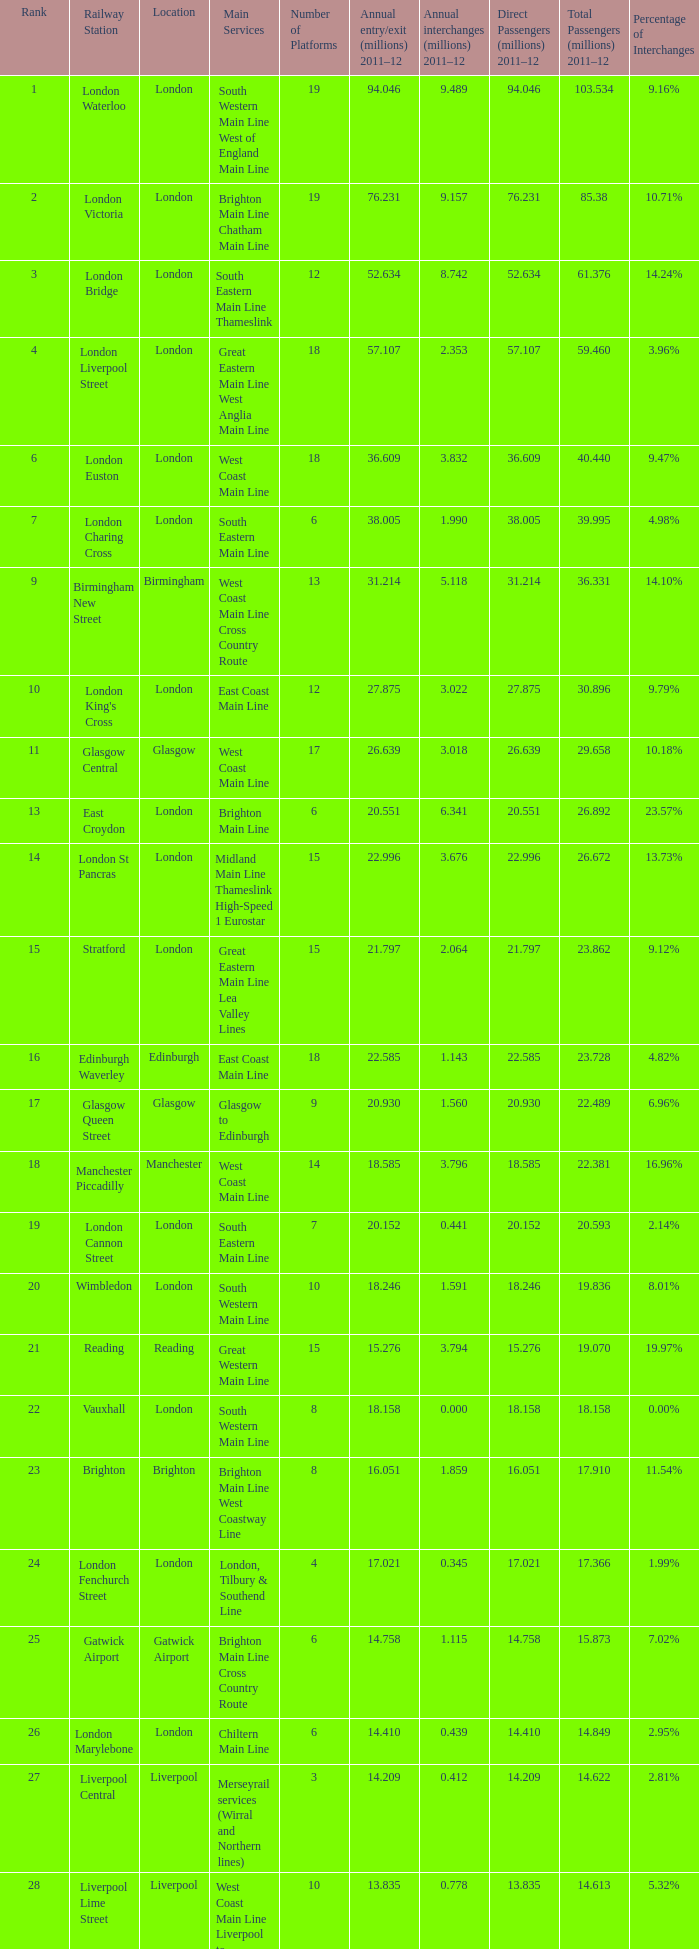How many annual interchanges in the millions occurred in 2011-12 when the number of annual entry/exits was 36.609 million?  3.832. 